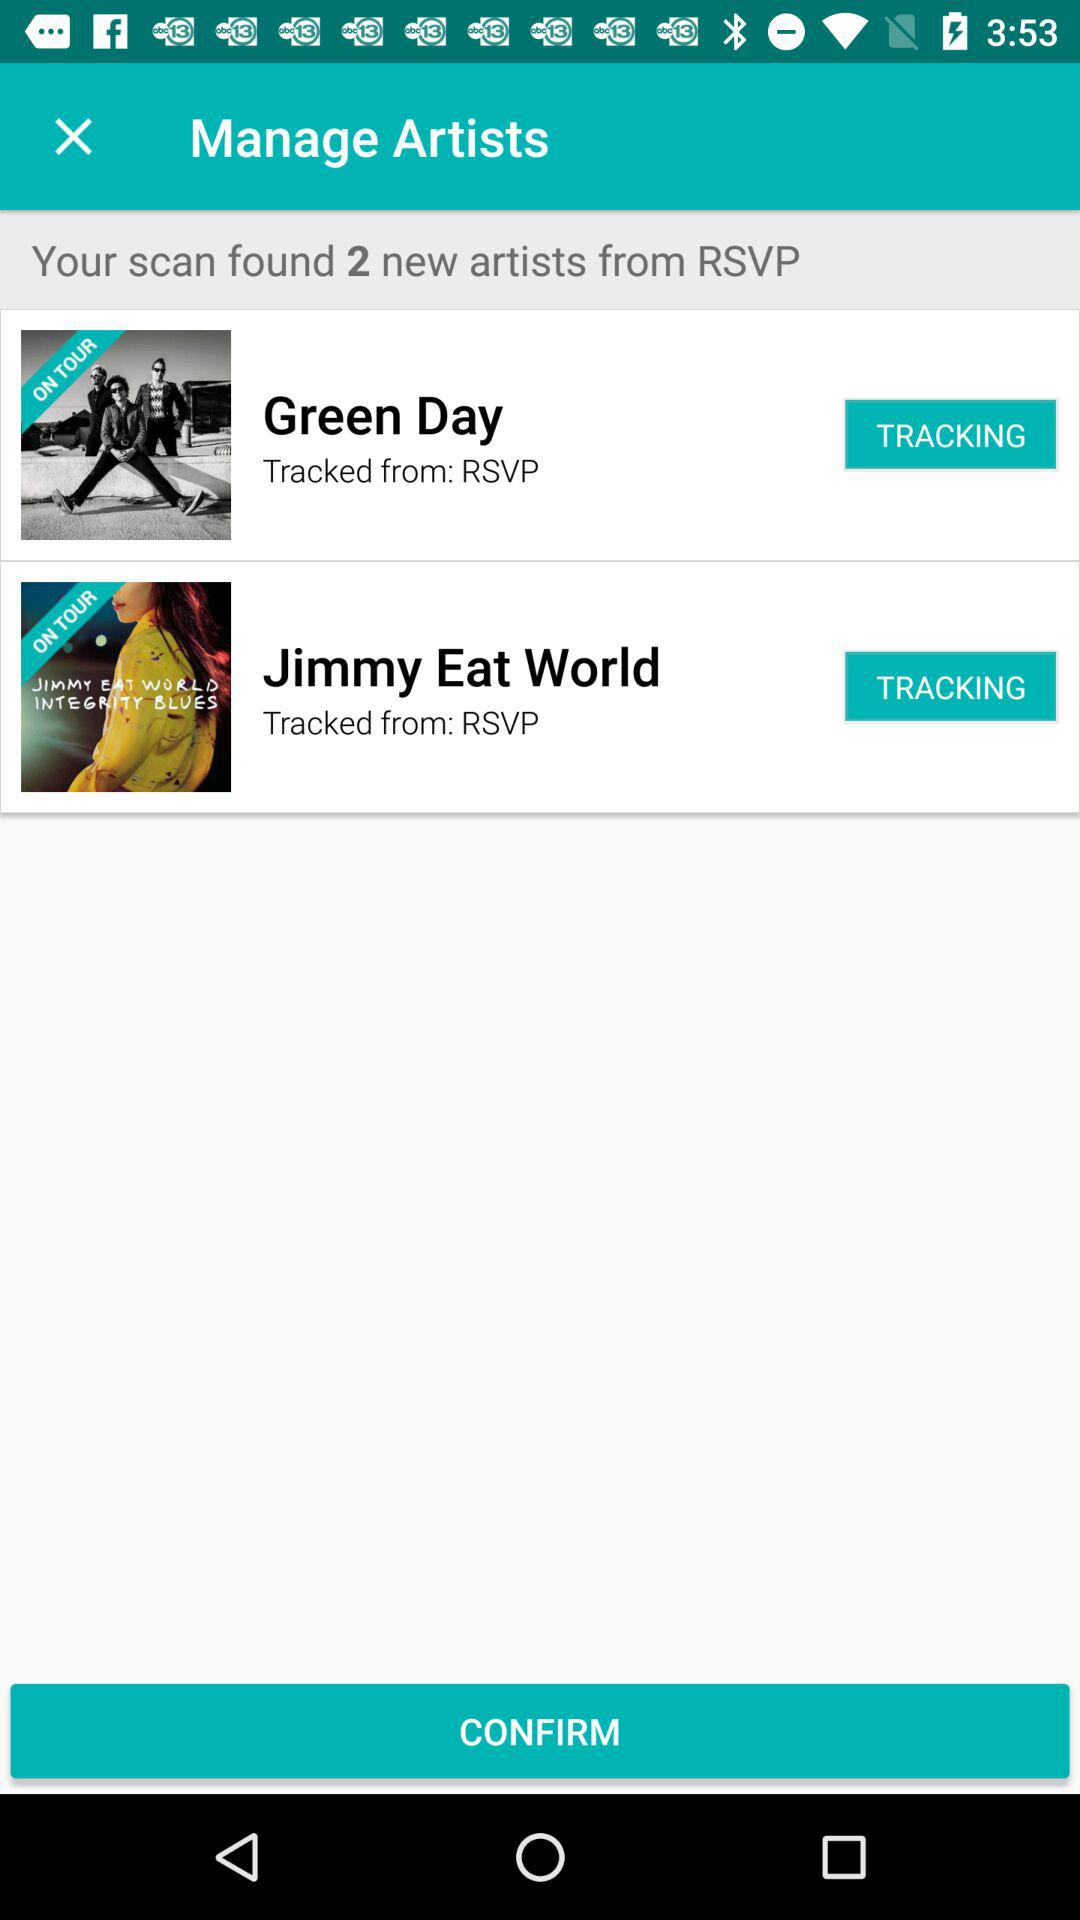How many artists were tracked from RSVP? Based on the screenshot provided, the app tracked two artists from RSVP, specifically Green Day and Jimmy Eat World. 